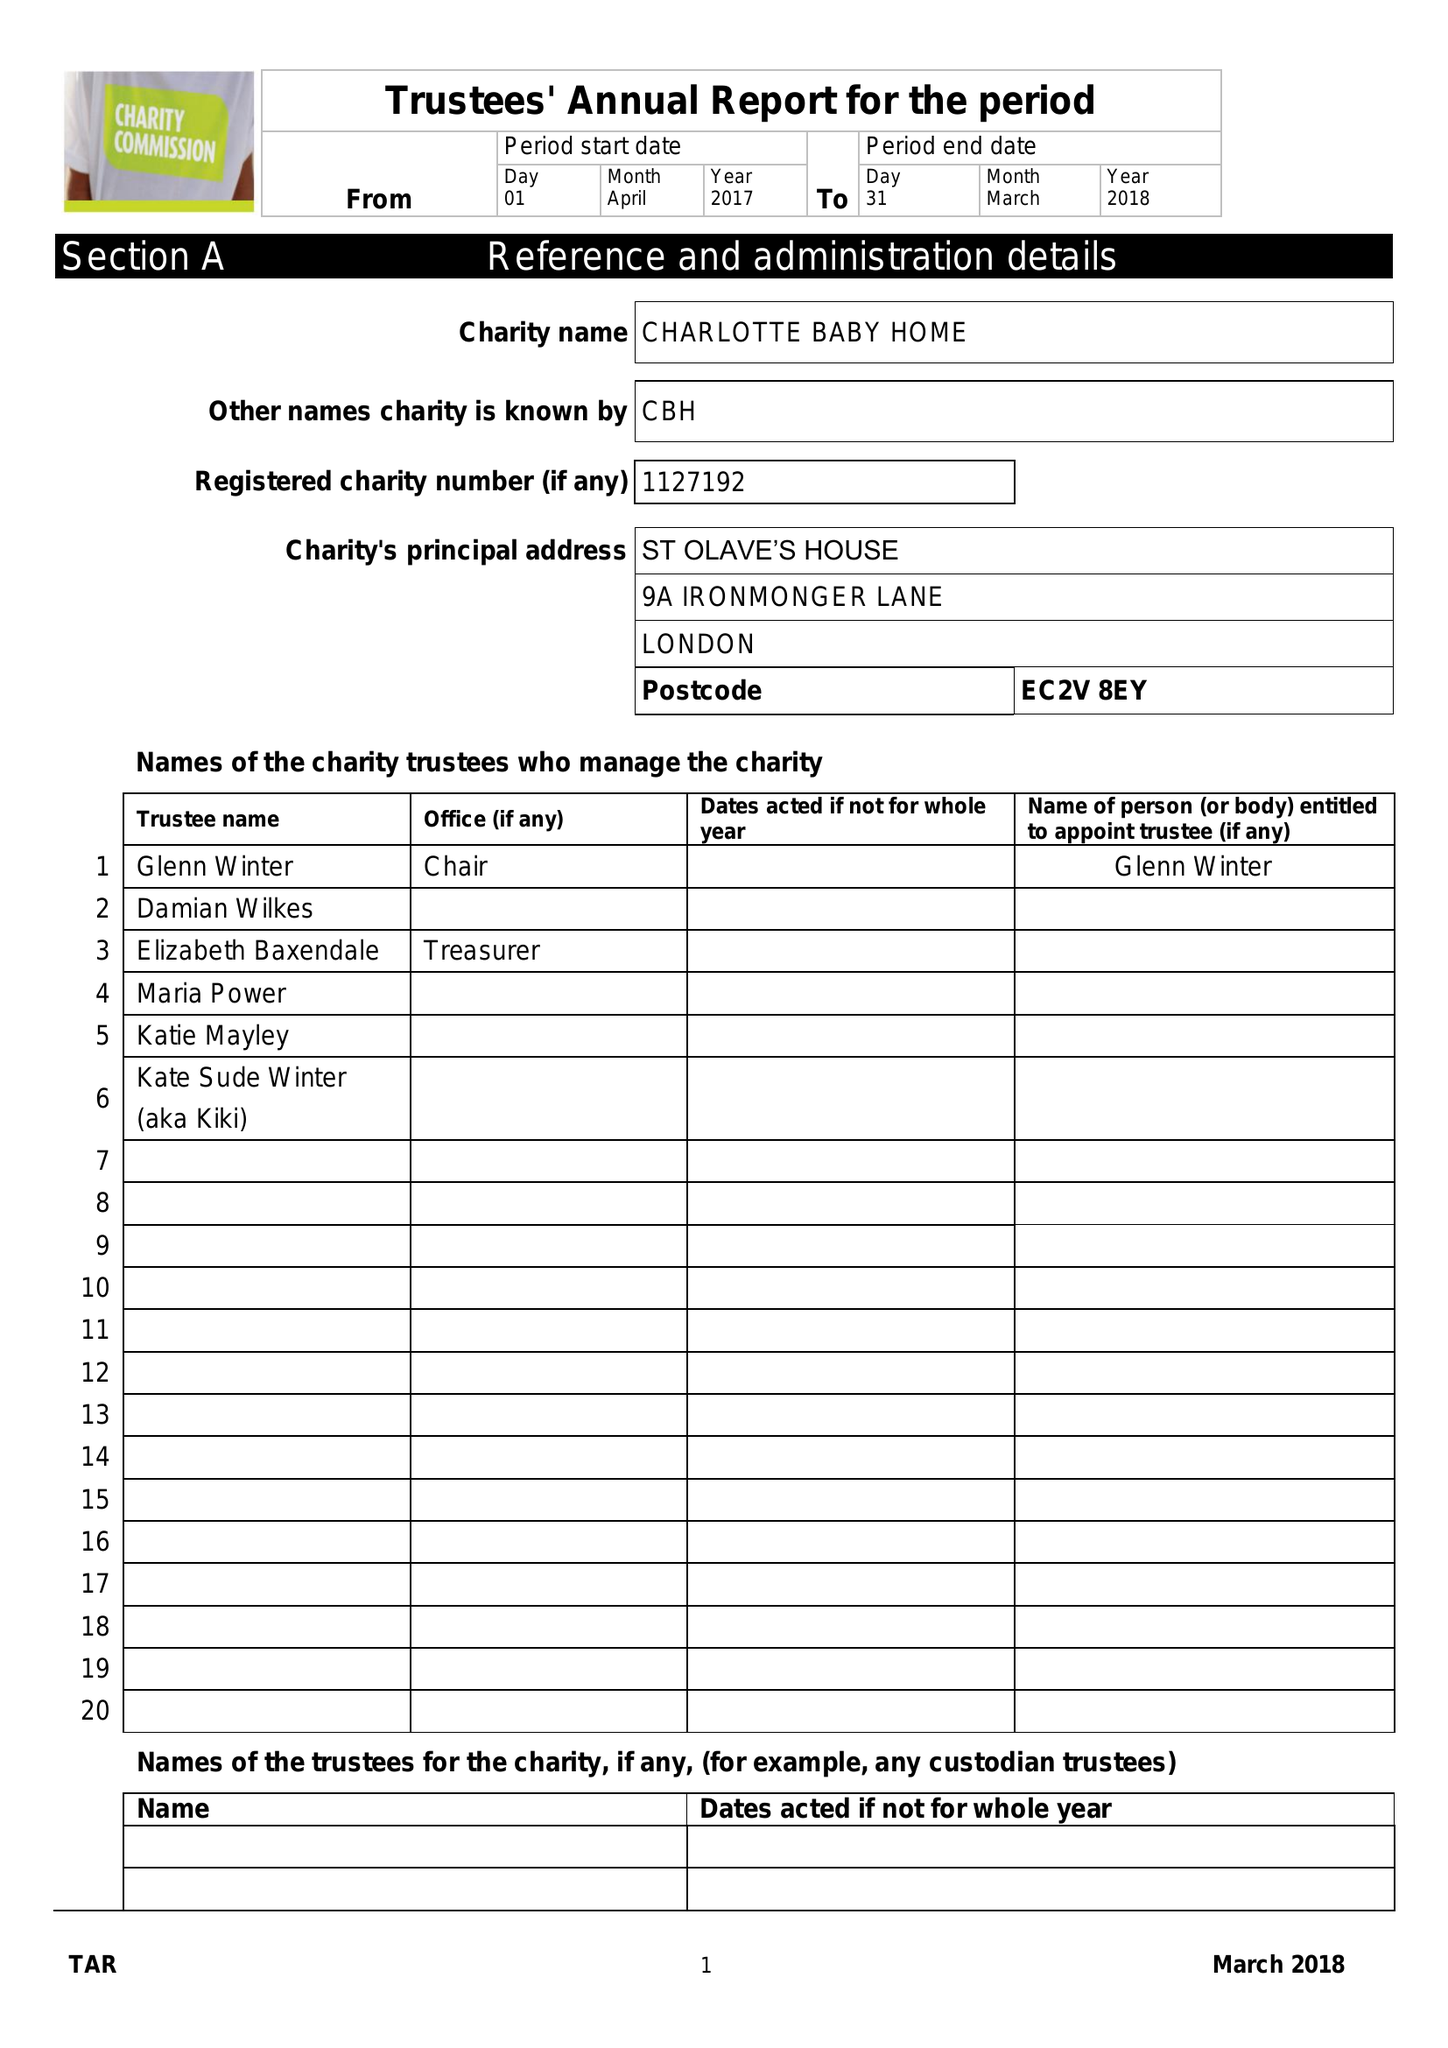What is the value for the address__street_line?
Answer the question using a single word or phrase. 9A IRONMONGER LANE 